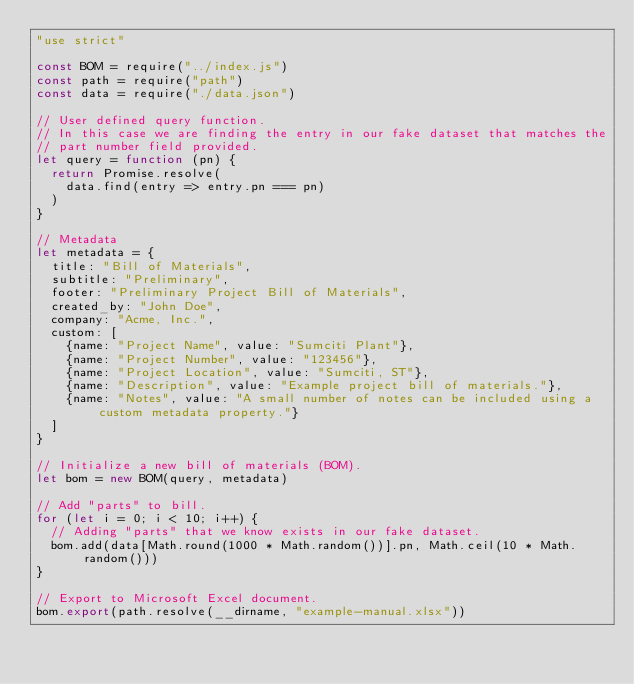<code> <loc_0><loc_0><loc_500><loc_500><_JavaScript_>"use strict"

const BOM = require("../index.js")
const path = require("path")
const data = require("./data.json")

// User defined query function.
// In this case we are finding the entry in our fake dataset that matches the 
// part number field provided.
let query = function (pn) {
	return Promise.resolve(
		data.find(entry => entry.pn === pn)
	)
}

// Metadata
let metadata = {
	title: "Bill of Materials",
	subtitle: "Preliminary",
	footer: "Preliminary Project Bill of Materials",
	created_by: "John Doe", 
	company: "Acme, Inc.",
	custom: [
		{name: "Project Name", value: "Sumciti Plant"},
		{name: "Project Number", value: "123456"},
		{name: "Project Location", value: "Sumciti, ST"},
		{name: "Description", value: "Example project bill of materials."},
		{name: "Notes", value: "A small number of notes can be included using a custom metadata property."}
	]
}

// Initialize a new bill of materials (BOM).
let bom = new BOM(query, metadata)

// Add "parts" to bill.
for (let i = 0; i < 10; i++) {
	// Adding "parts" that we know exists in our fake dataset.
	bom.add(data[Math.round(1000 * Math.random())].pn, Math.ceil(10 * Math.random()))
}

// Export to Microsoft Excel document.
bom.export(path.resolve(__dirname, "example-manual.xlsx"))</code> 